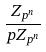Convert formula to latex. <formula><loc_0><loc_0><loc_500><loc_500>\frac { Z _ { p ^ { n } } } { p Z _ { p ^ { n } } }</formula> 